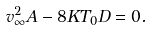Convert formula to latex. <formula><loc_0><loc_0><loc_500><loc_500>v _ { \infty } ^ { 2 } A - 8 K T _ { 0 } D = 0 .</formula> 